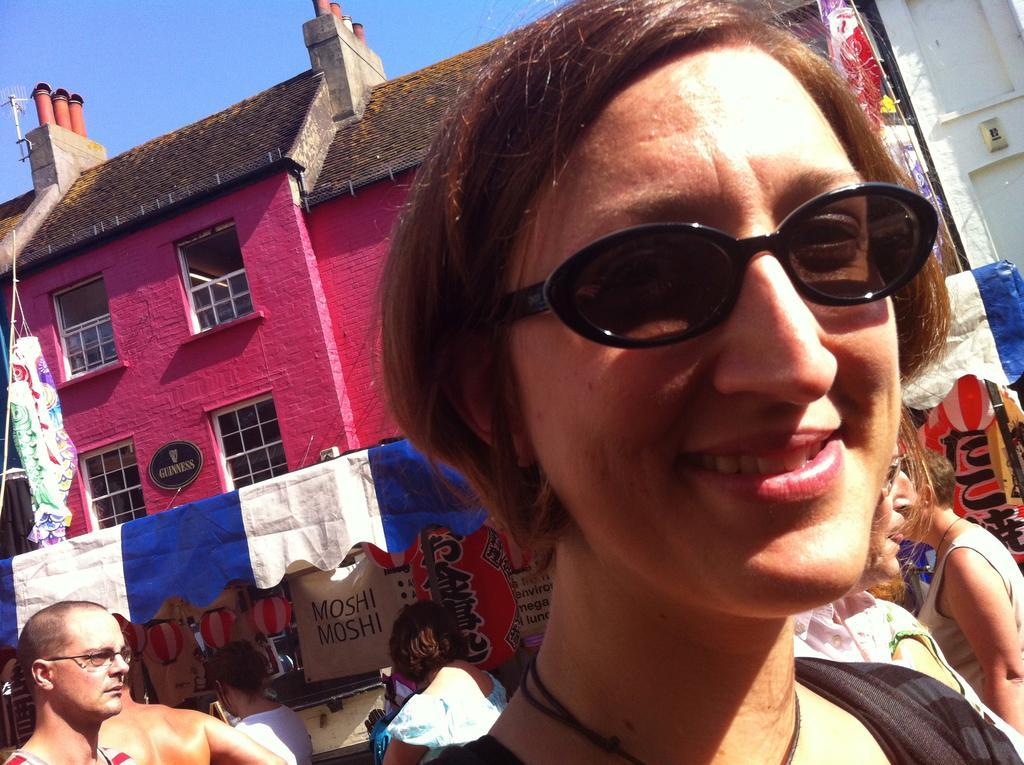How would you summarize this image in a sentence or two? In this image we can see there is a girl with a smile on her face, behind her there are few people. In the background there is a tent in front of the building and a sky. 